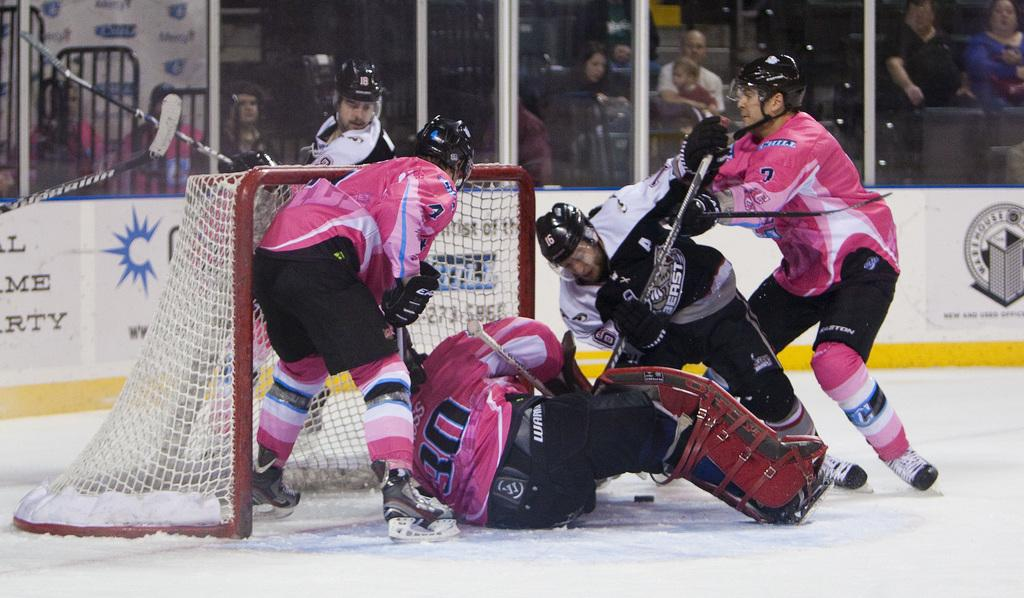<image>
Present a compact description of the photo's key features. The goalie in the pink uniform is wearing the number 30 